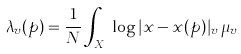Convert formula to latex. <formula><loc_0><loc_0><loc_500><loc_500>\lambda _ { v } ( p ) = \frac { 1 } { N } \int _ { X _ { v } } \log | x - x ( p ) | _ { v } \, \mu _ { v }</formula> 